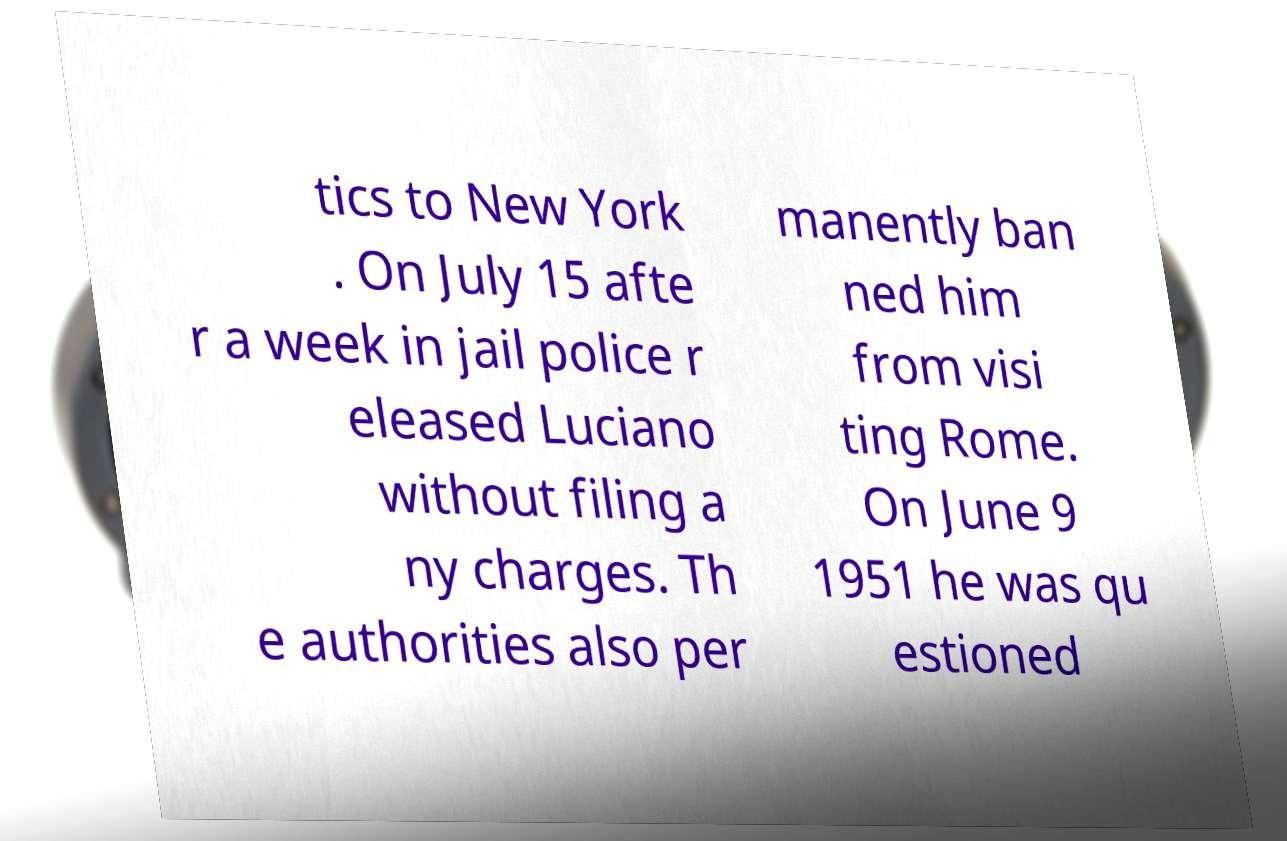Can you read and provide the text displayed in the image?This photo seems to have some interesting text. Can you extract and type it out for me? tics to New York . On July 15 afte r a week in jail police r eleased Luciano without filing a ny charges. Th e authorities also per manently ban ned him from visi ting Rome. On June 9 1951 he was qu estioned 